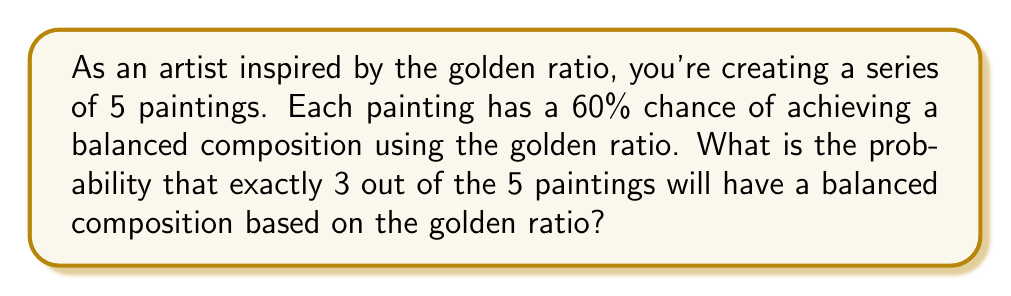Provide a solution to this math problem. To solve this problem, we'll use the binomial probability formula:

$$P(X = k) = \binom{n}{k} p^k (1-p)^{n-k}$$

Where:
$n$ = total number of trials (paintings) = 5
$k$ = number of successes (balanced compositions) = 3
$p$ = probability of success for each trial = 0.60

Step 1: Calculate the binomial coefficient
$$\binom{5}{3} = \frac{5!}{3!(5-3)!} = \frac{5 \cdot 4}{2 \cdot 1} = 10$$

Step 2: Calculate $p^k$
$$0.60^3 = 0.216$$

Step 3: Calculate $(1-p)^{n-k}$
$$(1-0.60)^{5-3} = 0.40^2 = 0.16$$

Step 4: Multiply all components
$$10 \cdot 0.216 \cdot 0.16 = 0.3456$$

Therefore, the probability of exactly 3 out of 5 paintings having a balanced composition using the golden ratio is 0.3456 or 34.56%.
Answer: 0.3456 